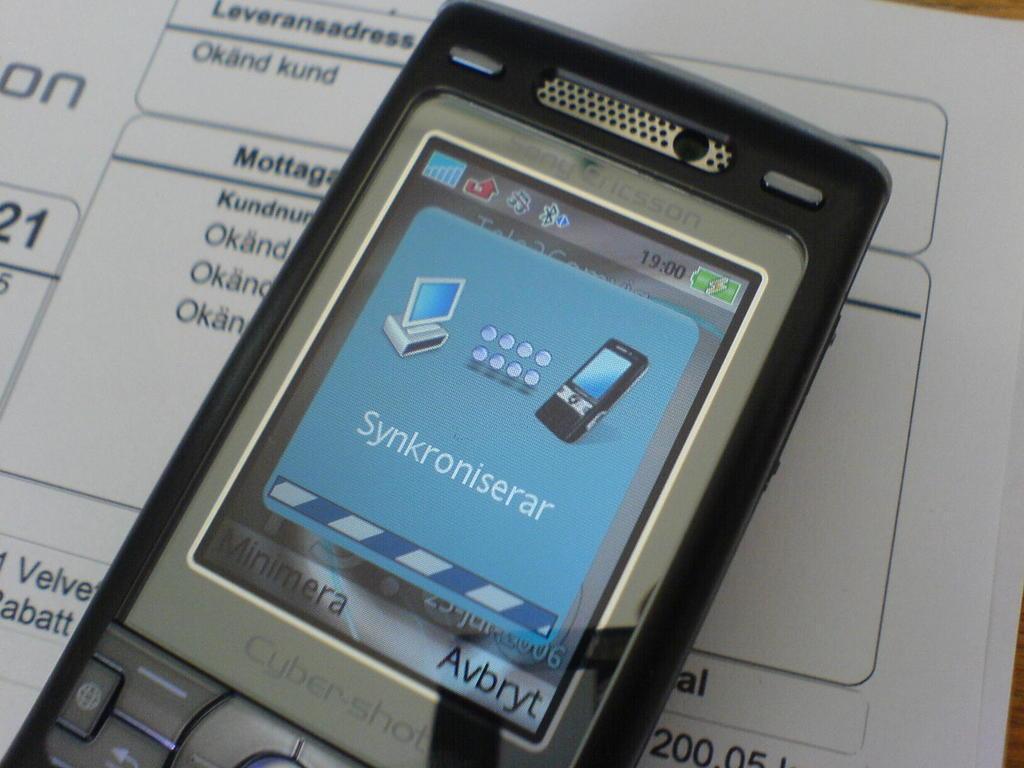What is the main object in the image? There is a table in the image. What is on the table? There are papers on the table. What can be seen on the papers? There is text on the papers. What electronic device is present on the papers? There is a mobile phone on the papers. How many potatoes are visible on the table in the image? There are no potatoes present in the image. What type of hill can be seen in the background of the image? There is no hill visible in the image; it only features a table, papers, text, and a mobile phone. 